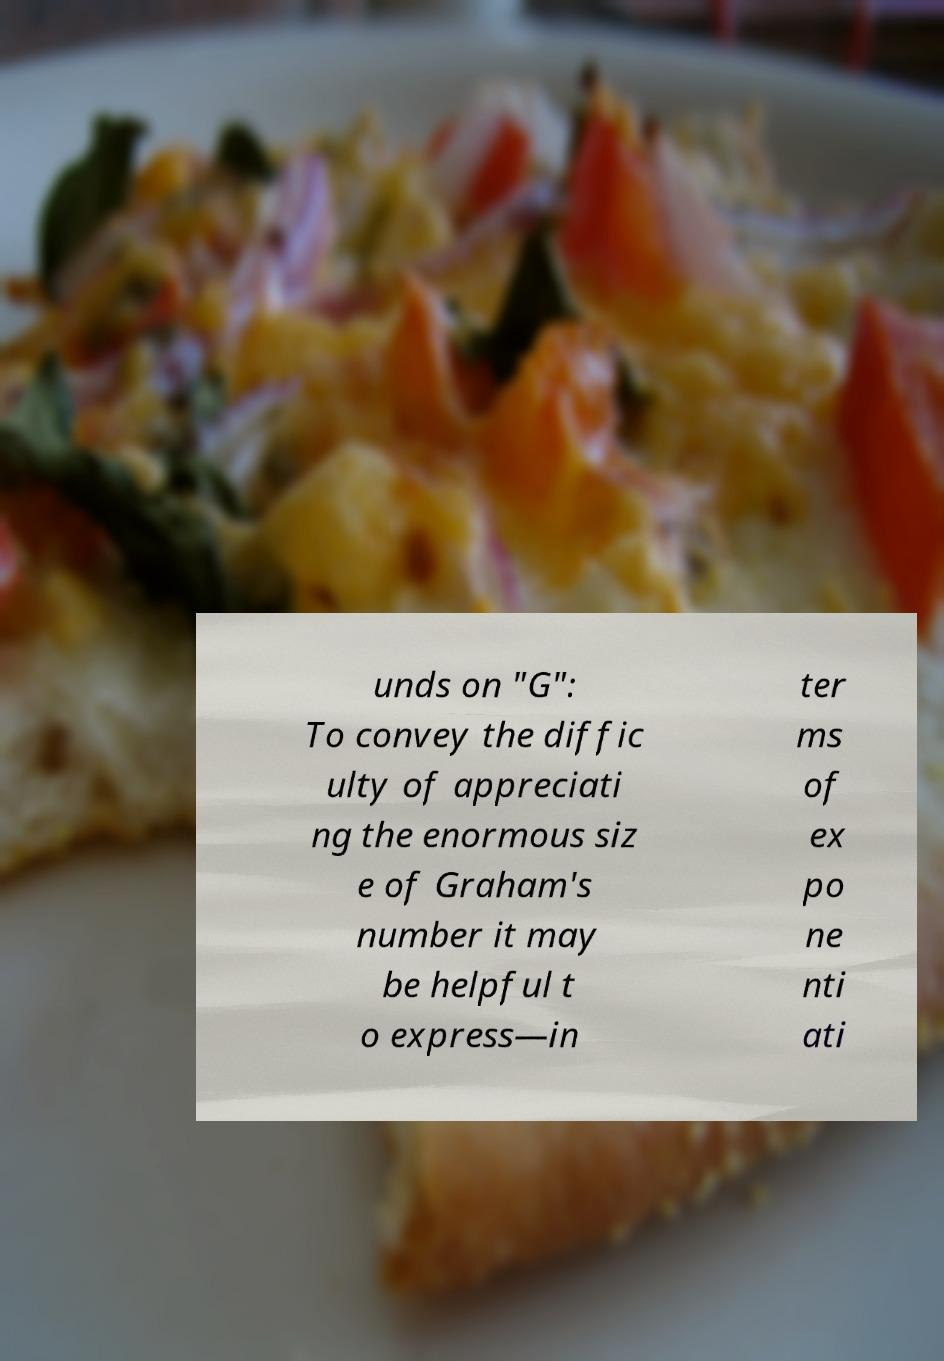For documentation purposes, I need the text within this image transcribed. Could you provide that? unds on "G": To convey the diffic ulty of appreciati ng the enormous siz e of Graham's number it may be helpful t o express—in ter ms of ex po ne nti ati 